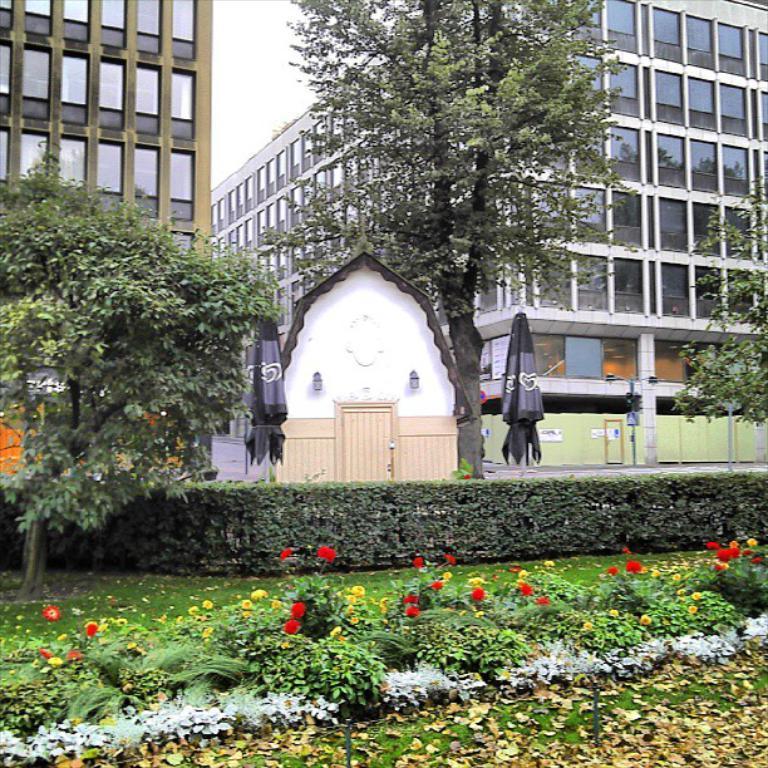How would you summarize this image in a sentence or two? In this picture I can see trees, plants and buildings. In the background I can see sky and other objects. 